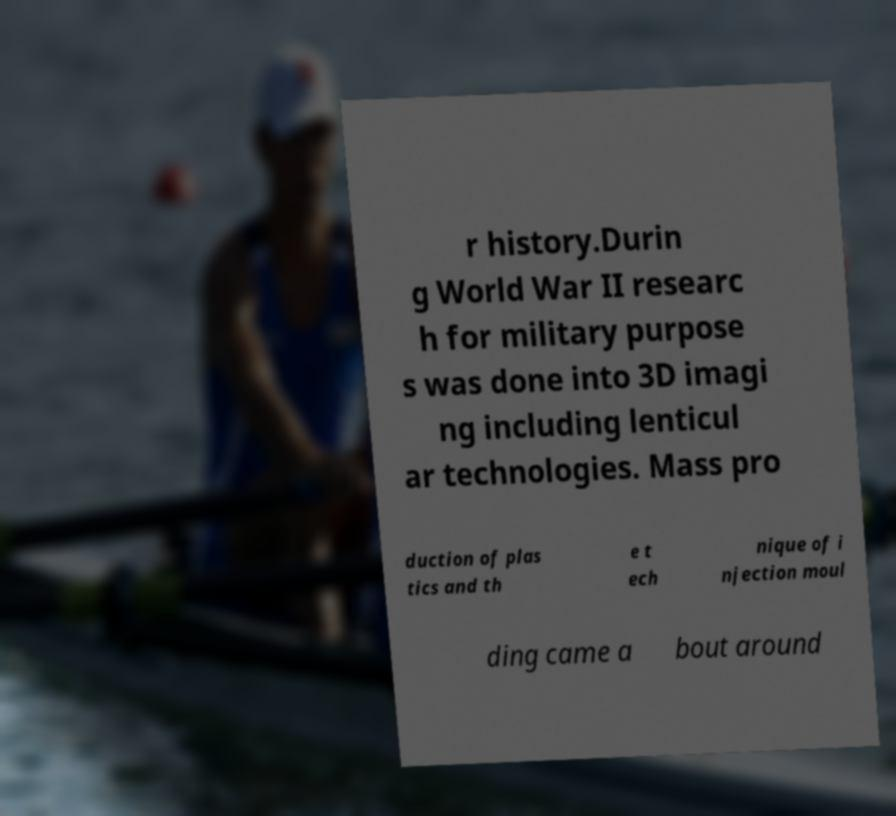Could you extract and type out the text from this image? r history.Durin g World War II researc h for military purpose s was done into 3D imagi ng including lenticul ar technologies. Mass pro duction of plas tics and th e t ech nique of i njection moul ding came a bout around 